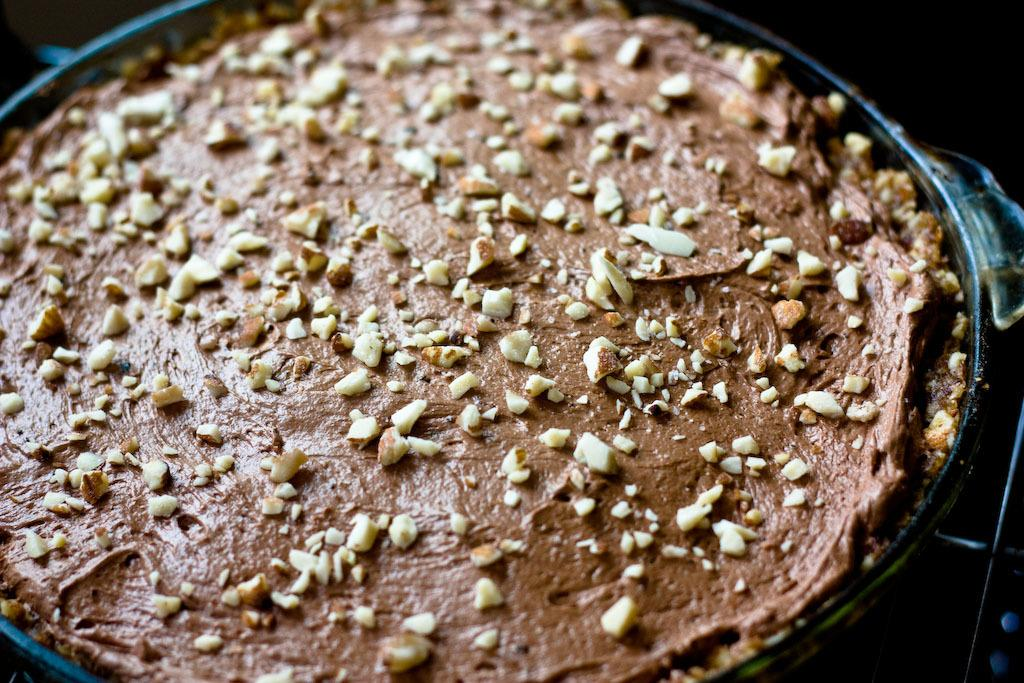What type of spread is visible in the image? There is a chocolate spread in the image. What is on top of the chocolate spread? There are chopped nuts on the chocolate spread. What type of pain can be seen in the image? There is no pain visible in the image; it features a chocolate spread with chopped nuts on top. What form of cakes are present in the image? There are no cakes present in the image; it only features a chocolate spread with chopped nuts. 